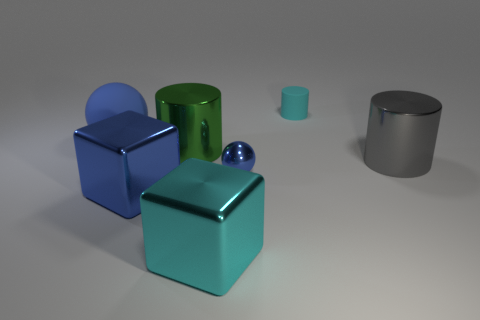Subtract all small matte cylinders. How many cylinders are left? 2 Add 1 cyan things. How many objects exist? 8 Subtract all cyan cubes. How many cubes are left? 1 Subtract all cylinders. How many objects are left? 4 Subtract 2 cylinders. How many cylinders are left? 1 Subtract all gray cylinders. How many gray spheres are left? 0 Subtract all large gray objects. Subtract all large purple metal cylinders. How many objects are left? 6 Add 2 big cyan things. How many big cyan things are left? 3 Add 3 cyan blocks. How many cyan blocks exist? 4 Subtract 0 gray cubes. How many objects are left? 7 